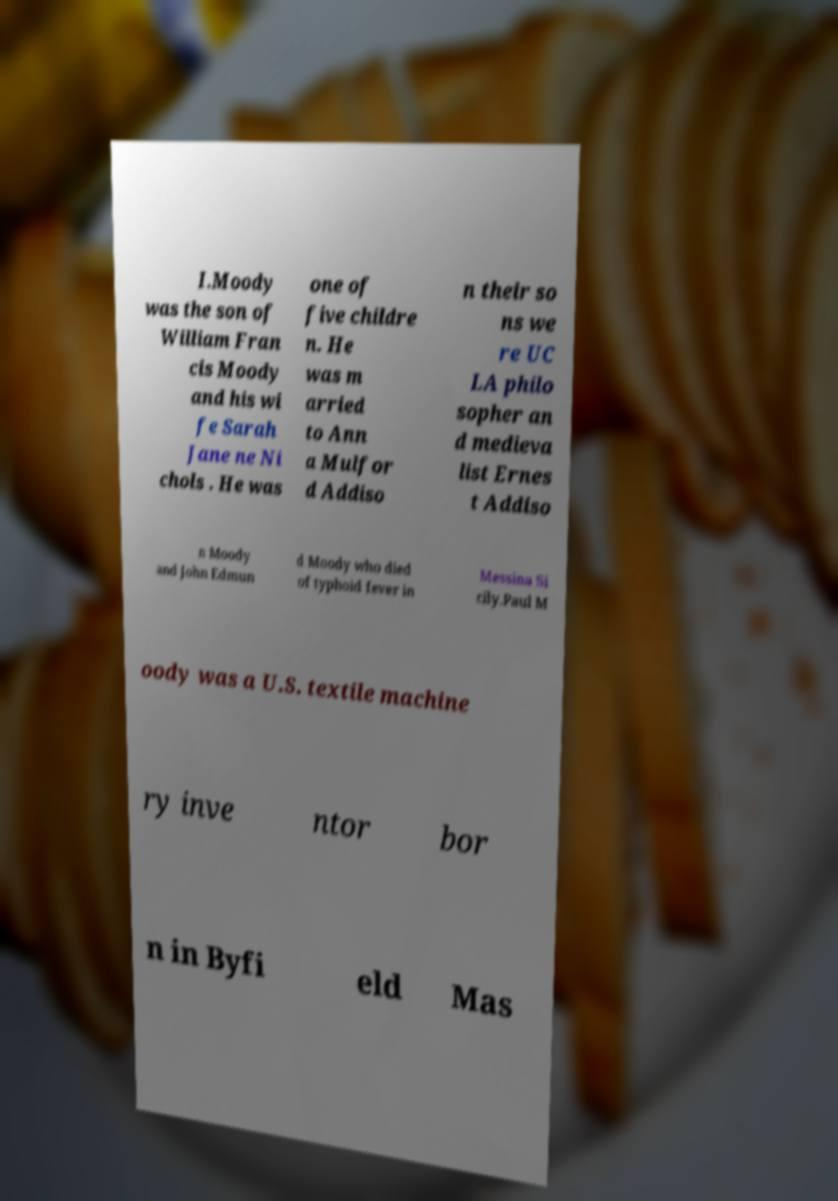There's text embedded in this image that I need extracted. Can you transcribe it verbatim? I.Moody was the son of William Fran cis Moody and his wi fe Sarah Jane ne Ni chols . He was one of five childre n. He was m arried to Ann a Mulfor d Addiso n their so ns we re UC LA philo sopher an d medieva list Ernes t Addiso n Moody and John Edmun d Moody who died of typhoid fever in Messina Si cily.Paul M oody was a U.S. textile machine ry inve ntor bor n in Byfi eld Mas 